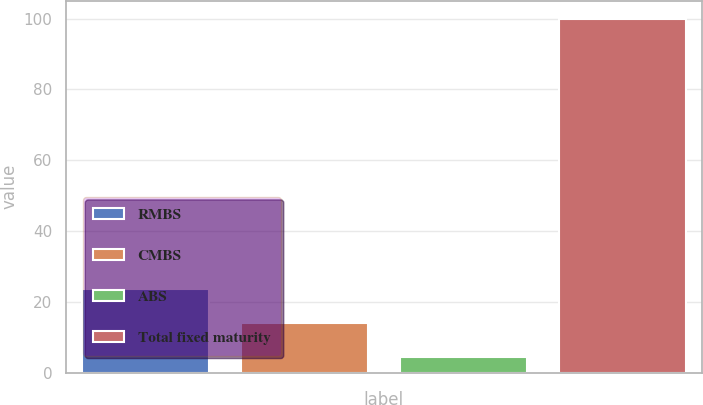Convert chart. <chart><loc_0><loc_0><loc_500><loc_500><bar_chart><fcel>RMBS<fcel>CMBS<fcel>ABS<fcel>Total fixed maturity<nl><fcel>23.52<fcel>13.96<fcel>4.4<fcel>100<nl></chart> 